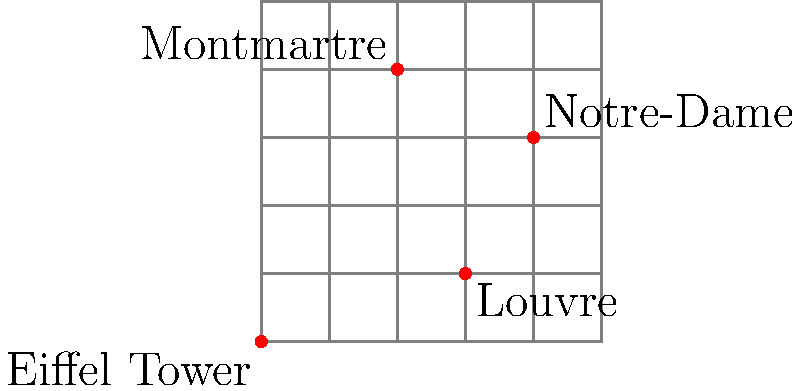Using the grid map of Paris neighborhoods where each square represents 1 km, calculate the total walking distance for a tourist route that starts at the Eiffel Tower, goes to Montmartre, then to Notre-Dame, and finally to the Louvre. Assume the tourist can only walk along the grid lines. Let's break down the route into segments:

1. Eiffel Tower to Montmartre:
   - Horizontal distance: 2 km east
   - Vertical distance: 4 km north
   - Total: 2 + 4 = 6 km

2. Montmartre to Notre-Dame:
   - Horizontal distance: 2 km east
   - Vertical distance: 1 km south
   - Total: 2 + 1 = 3 km

3. Notre-Dame to Louvre:
   - Horizontal distance: 1 km west
   - Vertical distance: 2 km south
   - Total: 1 + 2 = 3 km

Now, we sum up all segments:
$$ \text{Total distance} = 6 \text{ km} + 3 \text{ km} + 3 \text{ km} = 12 \text{ km} $$
Answer: 12 km 